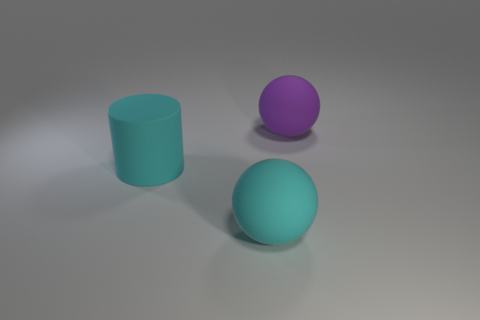Subtract all cylinders. How many objects are left? 2 Add 3 big green matte blocks. How many objects exist? 6 Add 2 purple objects. How many purple objects are left? 3 Add 1 cyan matte balls. How many cyan matte balls exist? 2 Subtract 1 cyan cylinders. How many objects are left? 2 Subtract all gray matte things. Subtract all large rubber things. How many objects are left? 0 